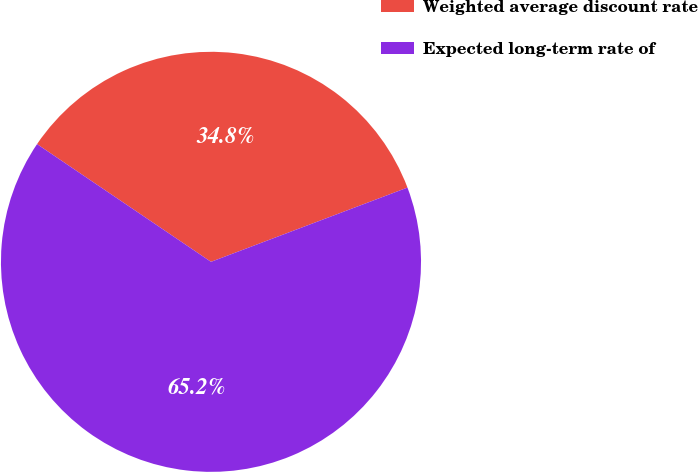Convert chart. <chart><loc_0><loc_0><loc_500><loc_500><pie_chart><fcel>Weighted average discount rate<fcel>Expected long-term rate of<nl><fcel>34.78%<fcel>65.22%<nl></chart> 